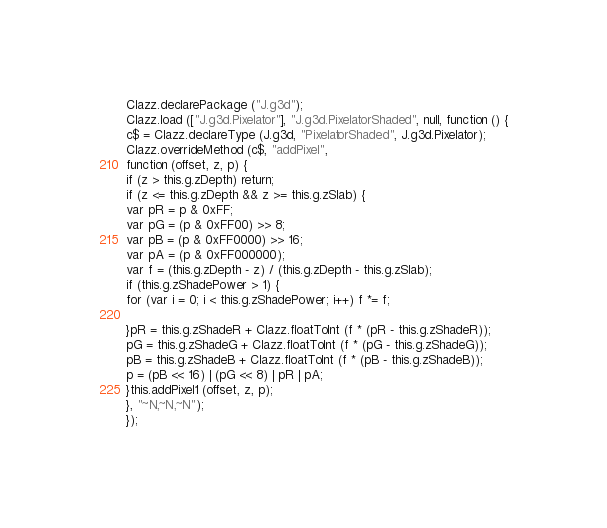Convert code to text. <code><loc_0><loc_0><loc_500><loc_500><_JavaScript_>Clazz.declarePackage ("J.g3d");
Clazz.load (["J.g3d.Pixelator"], "J.g3d.PixelatorShaded", null, function () {
c$ = Clazz.declareType (J.g3d, "PixelatorShaded", J.g3d.Pixelator);
Clazz.overrideMethod (c$, "addPixel", 
function (offset, z, p) {
if (z > this.g.zDepth) return;
if (z <= this.g.zDepth && z >= this.g.zSlab) {
var pR = p & 0xFF;
var pG = (p & 0xFF00) >> 8;
var pB = (p & 0xFF0000) >> 16;
var pA = (p & 0xFF000000);
var f = (this.g.zDepth - z) / (this.g.zDepth - this.g.zSlab);
if (this.g.zShadePower > 1) {
for (var i = 0; i < this.g.zShadePower; i++) f *= f;

}pR = this.g.zShadeR + Clazz.floatToInt (f * (pR - this.g.zShadeR));
pG = this.g.zShadeG + Clazz.floatToInt (f * (pG - this.g.zShadeG));
pB = this.g.zShadeB + Clazz.floatToInt (f * (pB - this.g.zShadeB));
p = (pB << 16) | (pG << 8) | pR | pA;
}this.addPixel1 (offset, z, p);
}, "~N,~N,~N");
});
</code> 